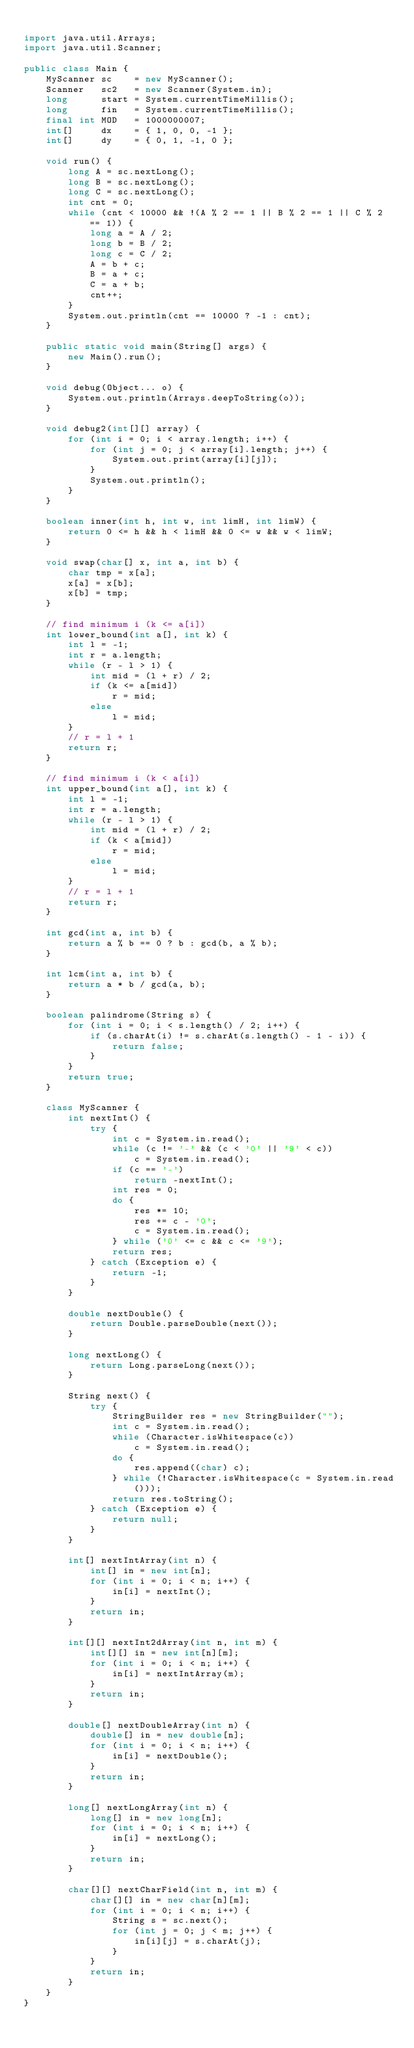Convert code to text. <code><loc_0><loc_0><loc_500><loc_500><_Java_>
import java.util.Arrays;
import java.util.Scanner;

public class Main {
    MyScanner sc    = new MyScanner();
    Scanner   sc2   = new Scanner(System.in);
    long      start = System.currentTimeMillis();
    long      fin   = System.currentTimeMillis();
    final int MOD   = 1000000007;
    int[]     dx    = { 1, 0, 0, -1 };
    int[]     dy    = { 0, 1, -1, 0 };

    void run() {
        long A = sc.nextLong();
        long B = sc.nextLong();
        long C = sc.nextLong();
        int cnt = 0;
        while (cnt < 10000 && !(A % 2 == 1 || B % 2 == 1 || C % 2 == 1)) {
            long a = A / 2;
            long b = B / 2;
            long c = C / 2;
            A = b + c;
            B = a + c;
            C = a + b;
            cnt++;
        }
        System.out.println(cnt == 10000 ? -1 : cnt);
    }

    public static void main(String[] args) {
        new Main().run();
    }

    void debug(Object... o) {
        System.out.println(Arrays.deepToString(o));
    }

    void debug2(int[][] array) {
        for (int i = 0; i < array.length; i++) {
            for (int j = 0; j < array[i].length; j++) {
                System.out.print(array[i][j]);
            }
            System.out.println();
        }
    }

    boolean inner(int h, int w, int limH, int limW) {
        return 0 <= h && h < limH && 0 <= w && w < limW;
    }

    void swap(char[] x, int a, int b) {
        char tmp = x[a];
        x[a] = x[b];
        x[b] = tmp;
    }

    // find minimum i (k <= a[i])
    int lower_bound(int a[], int k) {
        int l = -1;
        int r = a.length;
        while (r - l > 1) {
            int mid = (l + r) / 2;
            if (k <= a[mid])
                r = mid;
            else
                l = mid;
        }
        // r = l + 1
        return r;
    }

    // find minimum i (k < a[i])
    int upper_bound(int a[], int k) {
        int l = -1;
        int r = a.length;
        while (r - l > 1) {
            int mid = (l + r) / 2;
            if (k < a[mid])
                r = mid;
            else
                l = mid;
        }
        // r = l + 1
        return r;
    }

    int gcd(int a, int b) {
        return a % b == 0 ? b : gcd(b, a % b);
    }

    int lcm(int a, int b) {
        return a * b / gcd(a, b);
    }

    boolean palindrome(String s) {
        for (int i = 0; i < s.length() / 2; i++) {
            if (s.charAt(i) != s.charAt(s.length() - 1 - i)) {
                return false;
            }
        }
        return true;
    }

    class MyScanner {
        int nextInt() {
            try {
                int c = System.in.read();
                while (c != '-' && (c < '0' || '9' < c))
                    c = System.in.read();
                if (c == '-')
                    return -nextInt();
                int res = 0;
                do {
                    res *= 10;
                    res += c - '0';
                    c = System.in.read();
                } while ('0' <= c && c <= '9');
                return res;
            } catch (Exception e) {
                return -1;
            }
        }

        double nextDouble() {
            return Double.parseDouble(next());
        }

        long nextLong() {
            return Long.parseLong(next());
        }

        String next() {
            try {
                StringBuilder res = new StringBuilder("");
                int c = System.in.read();
                while (Character.isWhitespace(c))
                    c = System.in.read();
                do {
                    res.append((char) c);
                } while (!Character.isWhitespace(c = System.in.read()));
                return res.toString();
            } catch (Exception e) {
                return null;
            }
        }

        int[] nextIntArray(int n) {
            int[] in = new int[n];
            for (int i = 0; i < n; i++) {
                in[i] = nextInt();
            }
            return in;
        }

        int[][] nextInt2dArray(int n, int m) {
            int[][] in = new int[n][m];
            for (int i = 0; i < n; i++) {
                in[i] = nextIntArray(m);
            }
            return in;
        }

        double[] nextDoubleArray(int n) {
            double[] in = new double[n];
            for (int i = 0; i < n; i++) {
                in[i] = nextDouble();
            }
            return in;
        }

        long[] nextLongArray(int n) {
            long[] in = new long[n];
            for (int i = 0; i < n; i++) {
                in[i] = nextLong();
            }
            return in;
        }

        char[][] nextCharField(int n, int m) {
            char[][] in = new char[n][m];
            for (int i = 0; i < n; i++) {
                String s = sc.next();
                for (int j = 0; j < m; j++) {
                    in[i][j] = s.charAt(j);
                }
            }
            return in;
        }
    }
}</code> 